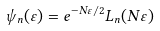<formula> <loc_0><loc_0><loc_500><loc_500>\psi _ { n } ( \varepsilon ) = e ^ { - N \varepsilon / 2 } L _ { n } ( N \varepsilon )</formula> 